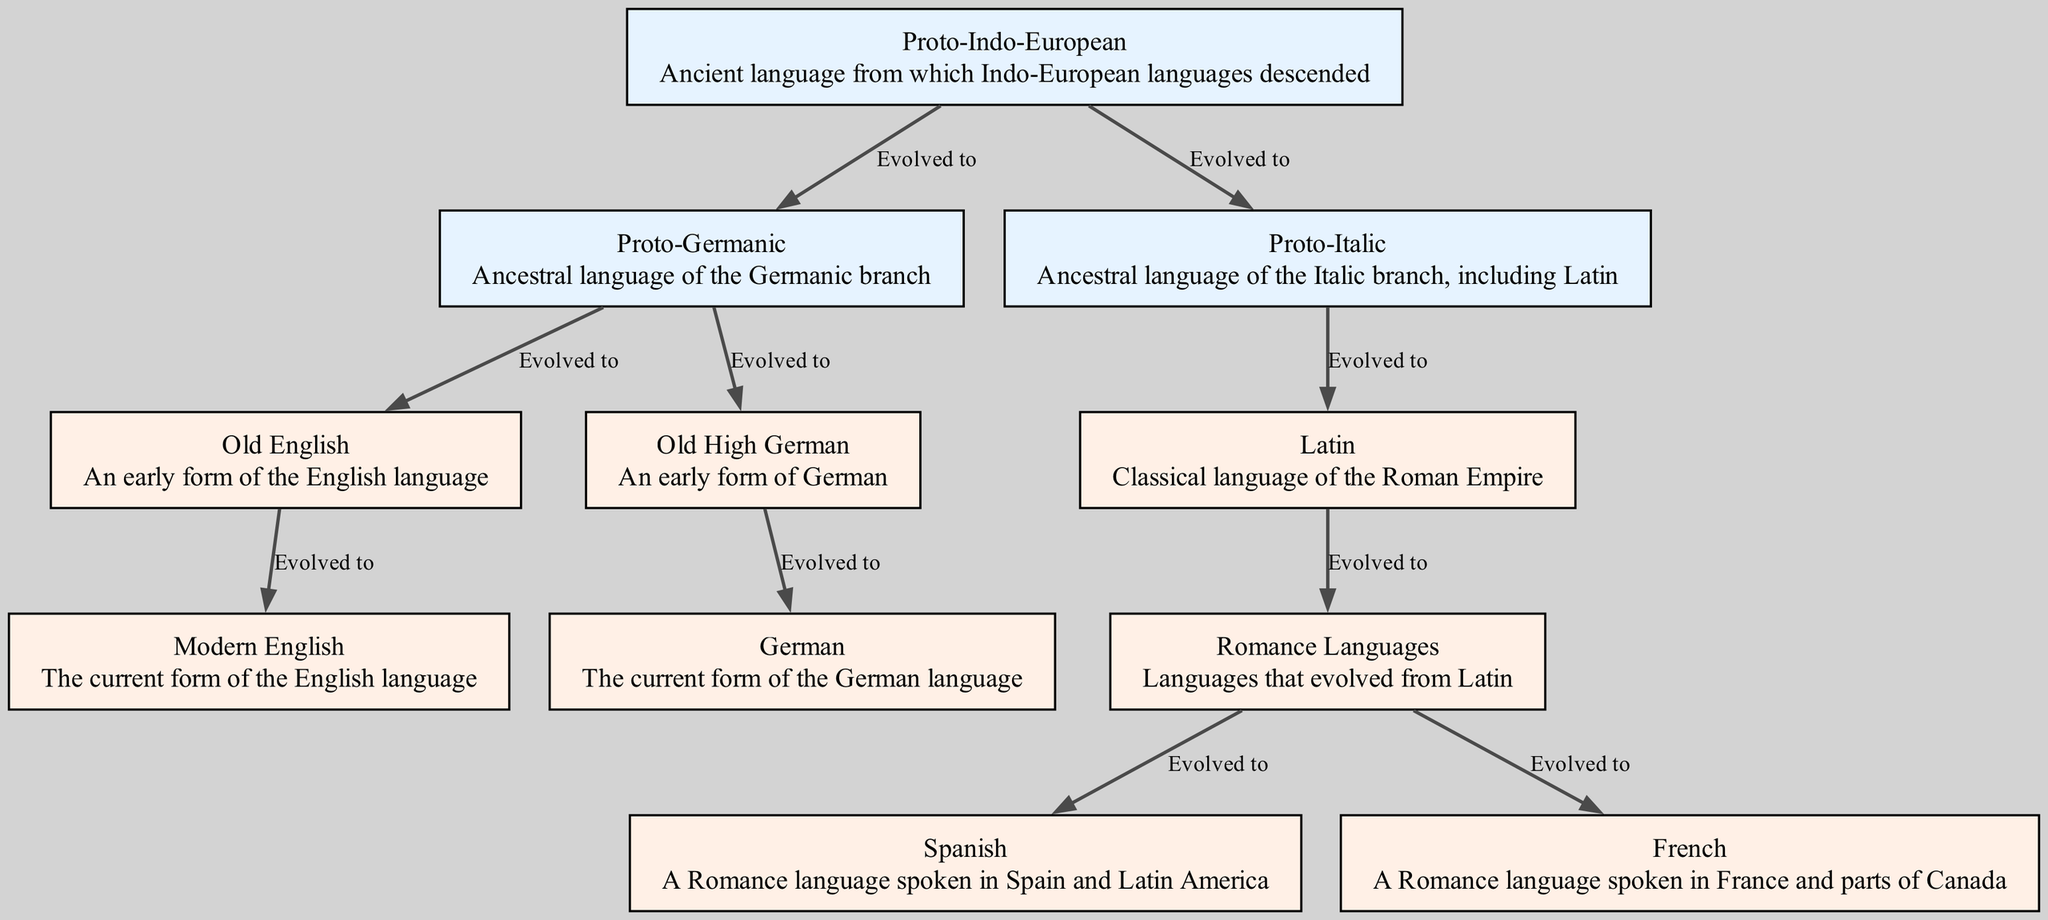What is the root of the language family tree? The diagram displays Proto-Indo-European as the topmost node, indicating it is the ancient language from which numerous languages evolved.
Answer: Proto-Indo-European How many languages evolved from Proto-Germanic? By analyzing the diagram, it can be seen that there are two languages (Old English and Old High German) that branch off from Proto-Germanic, which indicates how the languages have evolved.
Answer: 2 What is the modern form of Old High German? The diagram shows that Old High German evolved into the current form known simply as German, indicating its direct lineage.
Answer: German Which language is a descendant of Latin? The diagram clearly indicates that Romance Languages evolved from Latin, showing the direct connection between the two.
Answer: Romance Languages What are the two modern Romance languages shown in the diagram? The diagram includes two distinct branches from Romance Languages: Spanish and French, both of which are highlighted as separate evolutions.
Answer: Spanish, French How does Modern English relate to Old English? The diagram indicates that Modern English evolved from Old English, demonstrating a clear progression in the linguistic lineage.
Answer: Evolved to What type of languages evolved from Latin? The diagram specifies that languages like Spanish and French, among others, evolved specifically from the Romance Languages branch, which in turn evolved from Latin.
Answer: Romance Languages Which proto-language is the ancestor of Latin? The diagram reveals that Latin originates from Proto-Italic, which is directly linked above it in the genealogy flow.
Answer: Proto-Italic How many edges connect from Proto-Indo-European to its descendants? The diagram exhibits four edges leading from Proto-Indo-European, connecting to both Proto-Germanic and Proto-Italic, which subsequently branch into their respective languages.
Answer: 4 